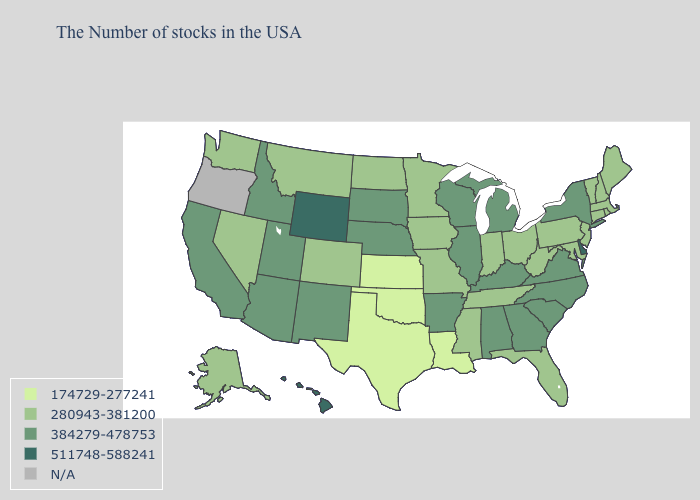Name the states that have a value in the range 511748-588241?
Give a very brief answer. Delaware, Wyoming, Hawaii. What is the highest value in states that border South Carolina?
Give a very brief answer. 384279-478753. Name the states that have a value in the range 511748-588241?
Answer briefly. Delaware, Wyoming, Hawaii. Is the legend a continuous bar?
Short answer required. No. What is the lowest value in states that border Alabama?
Answer briefly. 280943-381200. Name the states that have a value in the range 384279-478753?
Give a very brief answer. New York, Virginia, North Carolina, South Carolina, Georgia, Michigan, Kentucky, Alabama, Wisconsin, Illinois, Arkansas, Nebraska, South Dakota, New Mexico, Utah, Arizona, Idaho, California. What is the lowest value in the West?
Quick response, please. 280943-381200. Among the states that border Pennsylvania , which have the highest value?
Keep it brief. Delaware. Name the states that have a value in the range 384279-478753?
Concise answer only. New York, Virginia, North Carolina, South Carolina, Georgia, Michigan, Kentucky, Alabama, Wisconsin, Illinois, Arkansas, Nebraska, South Dakota, New Mexico, Utah, Arizona, Idaho, California. What is the lowest value in states that border Missouri?
Quick response, please. 174729-277241. What is the value of Rhode Island?
Give a very brief answer. 280943-381200. How many symbols are there in the legend?
Give a very brief answer. 5. What is the value of New Mexico?
Write a very short answer. 384279-478753. Among the states that border Texas , which have the highest value?
Short answer required. Arkansas, New Mexico. Does Alaska have the lowest value in the West?
Keep it brief. Yes. 